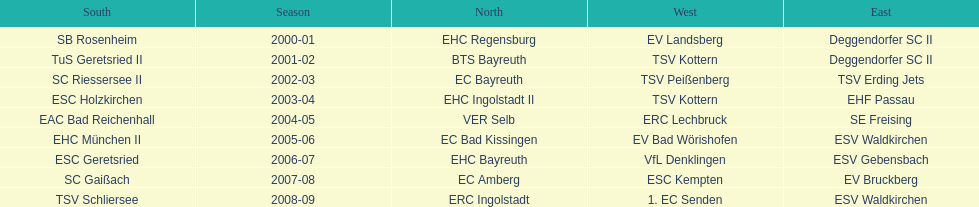Which name appears more often, kottern or bayreuth? Bayreuth. 